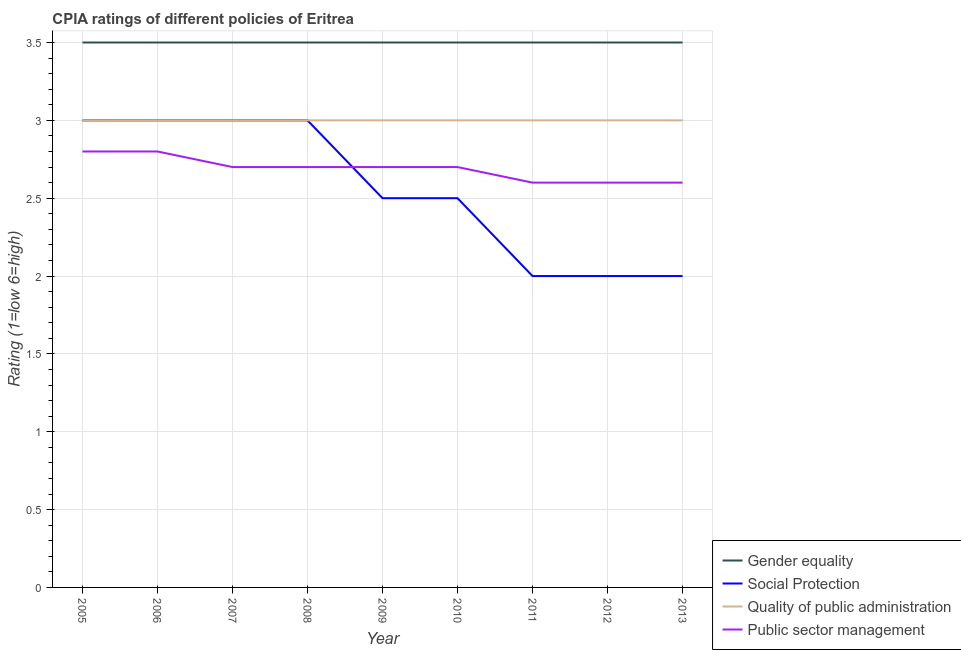Is the number of lines equal to the number of legend labels?
Offer a very short reply. Yes. Across all years, what is the minimum cpia rating of quality of public administration?
Ensure brevity in your answer.  3. What is the total cpia rating of public sector management in the graph?
Your answer should be very brief. 24.2. What is the difference between the cpia rating of gender equality in 2012 and that in 2013?
Your response must be concise. 0. What is the difference between the cpia rating of gender equality in 2011 and the cpia rating of public sector management in 2005?
Ensure brevity in your answer.  0.7. What is the average cpia rating of social protection per year?
Your answer should be very brief. 2.56. In the year 2012, what is the difference between the cpia rating of gender equality and cpia rating of public sector management?
Provide a succinct answer. 0.9. In how many years, is the cpia rating of quality of public administration greater than 2?
Offer a very short reply. 9. What is the ratio of the cpia rating of public sector management in 2005 to that in 2009?
Offer a very short reply. 1.04. What is the difference between the highest and the second highest cpia rating of social protection?
Make the answer very short. 0. What is the difference between the highest and the lowest cpia rating of public sector management?
Make the answer very short. 0.2. Is it the case that in every year, the sum of the cpia rating of social protection and cpia rating of gender equality is greater than the sum of cpia rating of public sector management and cpia rating of quality of public administration?
Keep it short and to the point. No. How many lines are there?
Your answer should be compact. 4. How many years are there in the graph?
Give a very brief answer. 9. What is the difference between two consecutive major ticks on the Y-axis?
Provide a short and direct response. 0.5. Where does the legend appear in the graph?
Provide a succinct answer. Bottom right. How many legend labels are there?
Make the answer very short. 4. What is the title of the graph?
Provide a short and direct response. CPIA ratings of different policies of Eritrea. Does "Quality Certification" appear as one of the legend labels in the graph?
Make the answer very short. No. What is the label or title of the Y-axis?
Provide a succinct answer. Rating (1=low 6=high). What is the Rating (1=low 6=high) of Gender equality in 2005?
Offer a very short reply. 3.5. What is the Rating (1=low 6=high) in Gender equality in 2006?
Provide a short and direct response. 3.5. What is the Rating (1=low 6=high) in Quality of public administration in 2006?
Your response must be concise. 3. What is the Rating (1=low 6=high) of Public sector management in 2006?
Provide a short and direct response. 2.8. What is the Rating (1=low 6=high) in Social Protection in 2008?
Offer a terse response. 3. What is the Rating (1=low 6=high) of Gender equality in 2009?
Your response must be concise. 3.5. What is the Rating (1=low 6=high) of Social Protection in 2009?
Your answer should be compact. 2.5. What is the Rating (1=low 6=high) in Public sector management in 2009?
Make the answer very short. 2.7. What is the Rating (1=low 6=high) in Social Protection in 2010?
Your answer should be compact. 2.5. What is the Rating (1=low 6=high) in Quality of public administration in 2010?
Keep it short and to the point. 3. What is the Rating (1=low 6=high) in Social Protection in 2011?
Give a very brief answer. 2. What is the Rating (1=low 6=high) of Quality of public administration in 2011?
Your answer should be compact. 3. What is the Rating (1=low 6=high) in Public sector management in 2011?
Offer a terse response. 2.6. What is the Rating (1=low 6=high) in Public sector management in 2012?
Give a very brief answer. 2.6. What is the Rating (1=low 6=high) of Gender equality in 2013?
Ensure brevity in your answer.  3.5. What is the Rating (1=low 6=high) of Social Protection in 2013?
Make the answer very short. 2. What is the Rating (1=low 6=high) of Quality of public administration in 2013?
Offer a very short reply. 3. What is the Rating (1=low 6=high) in Public sector management in 2013?
Your answer should be very brief. 2.6. Across all years, what is the maximum Rating (1=low 6=high) of Social Protection?
Give a very brief answer. 3. Across all years, what is the maximum Rating (1=low 6=high) of Quality of public administration?
Ensure brevity in your answer.  3. Across all years, what is the minimum Rating (1=low 6=high) of Gender equality?
Provide a succinct answer. 3.5. What is the total Rating (1=low 6=high) of Gender equality in the graph?
Your answer should be very brief. 31.5. What is the total Rating (1=low 6=high) of Social Protection in the graph?
Your answer should be compact. 23. What is the total Rating (1=low 6=high) in Quality of public administration in the graph?
Provide a succinct answer. 27. What is the total Rating (1=low 6=high) of Public sector management in the graph?
Provide a succinct answer. 24.2. What is the difference between the Rating (1=low 6=high) of Social Protection in 2005 and that in 2006?
Your answer should be compact. 0. What is the difference between the Rating (1=low 6=high) of Public sector management in 2005 and that in 2006?
Provide a succinct answer. 0. What is the difference between the Rating (1=low 6=high) of Social Protection in 2005 and that in 2007?
Give a very brief answer. 0. What is the difference between the Rating (1=low 6=high) in Public sector management in 2005 and that in 2008?
Your answer should be very brief. 0.1. What is the difference between the Rating (1=low 6=high) of Quality of public administration in 2005 and that in 2009?
Provide a short and direct response. 0. What is the difference between the Rating (1=low 6=high) of Social Protection in 2005 and that in 2010?
Your answer should be compact. 0.5. What is the difference between the Rating (1=low 6=high) in Quality of public administration in 2005 and that in 2010?
Offer a terse response. 0. What is the difference between the Rating (1=low 6=high) of Social Protection in 2005 and that in 2011?
Offer a very short reply. 1. What is the difference between the Rating (1=low 6=high) in Public sector management in 2005 and that in 2011?
Provide a short and direct response. 0.2. What is the difference between the Rating (1=low 6=high) in Quality of public administration in 2005 and that in 2012?
Provide a succinct answer. 0. What is the difference between the Rating (1=low 6=high) in Public sector management in 2005 and that in 2012?
Provide a short and direct response. 0.2. What is the difference between the Rating (1=low 6=high) of Gender equality in 2005 and that in 2013?
Keep it short and to the point. 0. What is the difference between the Rating (1=low 6=high) in Social Protection in 2005 and that in 2013?
Provide a succinct answer. 1. What is the difference between the Rating (1=low 6=high) in Gender equality in 2006 and that in 2007?
Provide a succinct answer. 0. What is the difference between the Rating (1=low 6=high) of Public sector management in 2006 and that in 2007?
Provide a short and direct response. 0.1. What is the difference between the Rating (1=low 6=high) in Gender equality in 2006 and that in 2008?
Provide a short and direct response. 0. What is the difference between the Rating (1=low 6=high) in Social Protection in 2006 and that in 2008?
Ensure brevity in your answer.  0. What is the difference between the Rating (1=low 6=high) of Social Protection in 2006 and that in 2009?
Your answer should be very brief. 0.5. What is the difference between the Rating (1=low 6=high) in Quality of public administration in 2006 and that in 2009?
Provide a short and direct response. 0. What is the difference between the Rating (1=low 6=high) in Gender equality in 2006 and that in 2010?
Provide a short and direct response. 0. What is the difference between the Rating (1=low 6=high) in Quality of public administration in 2006 and that in 2010?
Your response must be concise. 0. What is the difference between the Rating (1=low 6=high) in Public sector management in 2006 and that in 2010?
Make the answer very short. 0.1. What is the difference between the Rating (1=low 6=high) in Gender equality in 2006 and that in 2011?
Offer a very short reply. 0. What is the difference between the Rating (1=low 6=high) of Social Protection in 2006 and that in 2011?
Make the answer very short. 1. What is the difference between the Rating (1=low 6=high) of Quality of public administration in 2006 and that in 2011?
Offer a very short reply. 0. What is the difference between the Rating (1=low 6=high) in Gender equality in 2006 and that in 2012?
Ensure brevity in your answer.  0. What is the difference between the Rating (1=low 6=high) in Social Protection in 2006 and that in 2012?
Provide a succinct answer. 1. What is the difference between the Rating (1=low 6=high) in Quality of public administration in 2006 and that in 2012?
Make the answer very short. 0. What is the difference between the Rating (1=low 6=high) in Public sector management in 2006 and that in 2012?
Your answer should be very brief. 0.2. What is the difference between the Rating (1=low 6=high) in Gender equality in 2006 and that in 2013?
Provide a succinct answer. 0. What is the difference between the Rating (1=low 6=high) in Quality of public administration in 2006 and that in 2013?
Your response must be concise. 0. What is the difference between the Rating (1=low 6=high) in Gender equality in 2007 and that in 2008?
Make the answer very short. 0. What is the difference between the Rating (1=low 6=high) of Gender equality in 2007 and that in 2009?
Your response must be concise. 0. What is the difference between the Rating (1=low 6=high) in Social Protection in 2007 and that in 2009?
Offer a terse response. 0.5. What is the difference between the Rating (1=low 6=high) in Gender equality in 2007 and that in 2010?
Provide a succinct answer. 0. What is the difference between the Rating (1=low 6=high) of Quality of public administration in 2007 and that in 2011?
Give a very brief answer. 0. What is the difference between the Rating (1=low 6=high) in Public sector management in 2007 and that in 2011?
Provide a short and direct response. 0.1. What is the difference between the Rating (1=low 6=high) of Gender equality in 2007 and that in 2012?
Offer a very short reply. 0. What is the difference between the Rating (1=low 6=high) of Social Protection in 2007 and that in 2012?
Your response must be concise. 1. What is the difference between the Rating (1=low 6=high) in Quality of public administration in 2007 and that in 2012?
Keep it short and to the point. 0. What is the difference between the Rating (1=low 6=high) in Gender equality in 2008 and that in 2009?
Keep it short and to the point. 0. What is the difference between the Rating (1=low 6=high) of Social Protection in 2008 and that in 2009?
Give a very brief answer. 0.5. What is the difference between the Rating (1=low 6=high) of Public sector management in 2008 and that in 2009?
Offer a very short reply. 0. What is the difference between the Rating (1=low 6=high) of Social Protection in 2008 and that in 2010?
Make the answer very short. 0.5. What is the difference between the Rating (1=low 6=high) of Public sector management in 2008 and that in 2010?
Your answer should be very brief. 0. What is the difference between the Rating (1=low 6=high) of Gender equality in 2008 and that in 2011?
Provide a short and direct response. 0. What is the difference between the Rating (1=low 6=high) of Quality of public administration in 2008 and that in 2011?
Offer a terse response. 0. What is the difference between the Rating (1=low 6=high) in Public sector management in 2008 and that in 2011?
Provide a short and direct response. 0.1. What is the difference between the Rating (1=low 6=high) in Gender equality in 2008 and that in 2012?
Offer a very short reply. 0. What is the difference between the Rating (1=low 6=high) in Social Protection in 2008 and that in 2012?
Your answer should be very brief. 1. What is the difference between the Rating (1=low 6=high) in Public sector management in 2008 and that in 2012?
Offer a terse response. 0.1. What is the difference between the Rating (1=low 6=high) in Public sector management in 2008 and that in 2013?
Your answer should be compact. 0.1. What is the difference between the Rating (1=low 6=high) of Gender equality in 2009 and that in 2010?
Your answer should be very brief. 0. What is the difference between the Rating (1=low 6=high) of Social Protection in 2009 and that in 2010?
Give a very brief answer. 0. What is the difference between the Rating (1=low 6=high) of Public sector management in 2009 and that in 2010?
Your answer should be compact. 0. What is the difference between the Rating (1=low 6=high) of Gender equality in 2009 and that in 2011?
Offer a terse response. 0. What is the difference between the Rating (1=low 6=high) of Social Protection in 2009 and that in 2011?
Give a very brief answer. 0.5. What is the difference between the Rating (1=low 6=high) in Quality of public administration in 2009 and that in 2011?
Provide a short and direct response. 0. What is the difference between the Rating (1=low 6=high) in Public sector management in 2009 and that in 2011?
Offer a very short reply. 0.1. What is the difference between the Rating (1=low 6=high) in Social Protection in 2009 and that in 2013?
Provide a succinct answer. 0.5. What is the difference between the Rating (1=low 6=high) of Quality of public administration in 2009 and that in 2013?
Give a very brief answer. 0. What is the difference between the Rating (1=low 6=high) in Public sector management in 2009 and that in 2013?
Keep it short and to the point. 0.1. What is the difference between the Rating (1=low 6=high) of Social Protection in 2010 and that in 2011?
Keep it short and to the point. 0.5. What is the difference between the Rating (1=low 6=high) in Social Protection in 2010 and that in 2012?
Give a very brief answer. 0.5. What is the difference between the Rating (1=low 6=high) of Public sector management in 2010 and that in 2012?
Your response must be concise. 0.1. What is the difference between the Rating (1=low 6=high) in Gender equality in 2010 and that in 2013?
Give a very brief answer. 0. What is the difference between the Rating (1=low 6=high) in Public sector management in 2010 and that in 2013?
Offer a very short reply. 0.1. What is the difference between the Rating (1=low 6=high) in Gender equality in 2011 and that in 2012?
Keep it short and to the point. 0. What is the difference between the Rating (1=low 6=high) in Social Protection in 2011 and that in 2012?
Your answer should be very brief. 0. What is the difference between the Rating (1=low 6=high) in Public sector management in 2011 and that in 2012?
Ensure brevity in your answer.  0. What is the difference between the Rating (1=low 6=high) in Public sector management in 2011 and that in 2013?
Your answer should be very brief. 0. What is the difference between the Rating (1=low 6=high) of Gender equality in 2012 and that in 2013?
Make the answer very short. 0. What is the difference between the Rating (1=low 6=high) of Social Protection in 2012 and that in 2013?
Give a very brief answer. 0. What is the difference between the Rating (1=low 6=high) of Quality of public administration in 2012 and that in 2013?
Provide a succinct answer. 0. What is the difference between the Rating (1=low 6=high) of Gender equality in 2005 and the Rating (1=low 6=high) of Social Protection in 2006?
Offer a terse response. 0.5. What is the difference between the Rating (1=low 6=high) of Gender equality in 2005 and the Rating (1=low 6=high) of Quality of public administration in 2006?
Provide a short and direct response. 0.5. What is the difference between the Rating (1=low 6=high) of Social Protection in 2005 and the Rating (1=low 6=high) of Quality of public administration in 2006?
Offer a very short reply. 0. What is the difference between the Rating (1=low 6=high) of Social Protection in 2005 and the Rating (1=low 6=high) of Public sector management in 2006?
Make the answer very short. 0.2. What is the difference between the Rating (1=low 6=high) of Quality of public administration in 2005 and the Rating (1=low 6=high) of Public sector management in 2006?
Give a very brief answer. 0.2. What is the difference between the Rating (1=low 6=high) of Gender equality in 2005 and the Rating (1=low 6=high) of Social Protection in 2007?
Ensure brevity in your answer.  0.5. What is the difference between the Rating (1=low 6=high) of Gender equality in 2005 and the Rating (1=low 6=high) of Quality of public administration in 2007?
Give a very brief answer. 0.5. What is the difference between the Rating (1=low 6=high) in Gender equality in 2005 and the Rating (1=low 6=high) in Public sector management in 2007?
Offer a terse response. 0.8. What is the difference between the Rating (1=low 6=high) in Social Protection in 2005 and the Rating (1=low 6=high) in Quality of public administration in 2007?
Give a very brief answer. 0. What is the difference between the Rating (1=low 6=high) in Social Protection in 2005 and the Rating (1=low 6=high) in Public sector management in 2007?
Ensure brevity in your answer.  0.3. What is the difference between the Rating (1=low 6=high) of Quality of public administration in 2005 and the Rating (1=low 6=high) of Public sector management in 2007?
Offer a very short reply. 0.3. What is the difference between the Rating (1=low 6=high) of Gender equality in 2005 and the Rating (1=low 6=high) of Quality of public administration in 2008?
Your answer should be very brief. 0.5. What is the difference between the Rating (1=low 6=high) in Gender equality in 2005 and the Rating (1=low 6=high) in Public sector management in 2008?
Your answer should be very brief. 0.8. What is the difference between the Rating (1=low 6=high) of Social Protection in 2005 and the Rating (1=low 6=high) of Quality of public administration in 2008?
Keep it short and to the point. 0. What is the difference between the Rating (1=low 6=high) of Social Protection in 2005 and the Rating (1=low 6=high) of Public sector management in 2008?
Offer a terse response. 0.3. What is the difference between the Rating (1=low 6=high) in Quality of public administration in 2005 and the Rating (1=low 6=high) in Public sector management in 2008?
Offer a terse response. 0.3. What is the difference between the Rating (1=low 6=high) of Gender equality in 2005 and the Rating (1=low 6=high) of Social Protection in 2009?
Offer a terse response. 1. What is the difference between the Rating (1=low 6=high) in Gender equality in 2005 and the Rating (1=low 6=high) in Quality of public administration in 2009?
Your answer should be compact. 0.5. What is the difference between the Rating (1=low 6=high) in Social Protection in 2005 and the Rating (1=low 6=high) in Quality of public administration in 2009?
Ensure brevity in your answer.  0. What is the difference between the Rating (1=low 6=high) in Social Protection in 2005 and the Rating (1=low 6=high) in Public sector management in 2009?
Give a very brief answer. 0.3. What is the difference between the Rating (1=low 6=high) in Gender equality in 2005 and the Rating (1=low 6=high) in Social Protection in 2010?
Keep it short and to the point. 1. What is the difference between the Rating (1=low 6=high) of Social Protection in 2005 and the Rating (1=low 6=high) of Quality of public administration in 2010?
Your answer should be very brief. 0. What is the difference between the Rating (1=low 6=high) of Social Protection in 2005 and the Rating (1=low 6=high) of Quality of public administration in 2011?
Give a very brief answer. 0. What is the difference between the Rating (1=low 6=high) of Social Protection in 2005 and the Rating (1=low 6=high) of Quality of public administration in 2012?
Offer a very short reply. 0. What is the difference between the Rating (1=low 6=high) of Social Protection in 2005 and the Rating (1=low 6=high) of Public sector management in 2012?
Keep it short and to the point. 0.4. What is the difference between the Rating (1=low 6=high) of Quality of public administration in 2005 and the Rating (1=low 6=high) of Public sector management in 2012?
Keep it short and to the point. 0.4. What is the difference between the Rating (1=low 6=high) of Gender equality in 2005 and the Rating (1=low 6=high) of Quality of public administration in 2013?
Make the answer very short. 0.5. What is the difference between the Rating (1=low 6=high) of Gender equality in 2005 and the Rating (1=low 6=high) of Public sector management in 2013?
Your answer should be very brief. 0.9. What is the difference between the Rating (1=low 6=high) in Social Protection in 2005 and the Rating (1=low 6=high) in Quality of public administration in 2013?
Your answer should be compact. 0. What is the difference between the Rating (1=low 6=high) in Quality of public administration in 2005 and the Rating (1=low 6=high) in Public sector management in 2013?
Your answer should be compact. 0.4. What is the difference between the Rating (1=low 6=high) in Gender equality in 2006 and the Rating (1=low 6=high) in Social Protection in 2007?
Provide a succinct answer. 0.5. What is the difference between the Rating (1=low 6=high) of Social Protection in 2006 and the Rating (1=low 6=high) of Quality of public administration in 2007?
Give a very brief answer. 0. What is the difference between the Rating (1=low 6=high) in Gender equality in 2006 and the Rating (1=low 6=high) in Public sector management in 2008?
Provide a short and direct response. 0.8. What is the difference between the Rating (1=low 6=high) of Social Protection in 2006 and the Rating (1=low 6=high) of Quality of public administration in 2008?
Offer a very short reply. 0. What is the difference between the Rating (1=low 6=high) of Quality of public administration in 2006 and the Rating (1=low 6=high) of Public sector management in 2008?
Ensure brevity in your answer.  0.3. What is the difference between the Rating (1=low 6=high) of Gender equality in 2006 and the Rating (1=low 6=high) of Social Protection in 2009?
Your answer should be compact. 1. What is the difference between the Rating (1=low 6=high) of Gender equality in 2006 and the Rating (1=low 6=high) of Quality of public administration in 2009?
Your response must be concise. 0.5. What is the difference between the Rating (1=low 6=high) in Gender equality in 2006 and the Rating (1=low 6=high) in Public sector management in 2009?
Offer a very short reply. 0.8. What is the difference between the Rating (1=low 6=high) in Social Protection in 2006 and the Rating (1=low 6=high) in Public sector management in 2009?
Your response must be concise. 0.3. What is the difference between the Rating (1=low 6=high) in Quality of public administration in 2006 and the Rating (1=low 6=high) in Public sector management in 2009?
Offer a very short reply. 0.3. What is the difference between the Rating (1=low 6=high) in Gender equality in 2006 and the Rating (1=low 6=high) in Quality of public administration in 2010?
Make the answer very short. 0.5. What is the difference between the Rating (1=low 6=high) of Gender equality in 2006 and the Rating (1=low 6=high) of Public sector management in 2010?
Ensure brevity in your answer.  0.8. What is the difference between the Rating (1=low 6=high) of Social Protection in 2006 and the Rating (1=low 6=high) of Quality of public administration in 2010?
Your response must be concise. 0. What is the difference between the Rating (1=low 6=high) in Gender equality in 2006 and the Rating (1=low 6=high) in Quality of public administration in 2011?
Your response must be concise. 0.5. What is the difference between the Rating (1=low 6=high) in Gender equality in 2006 and the Rating (1=low 6=high) in Public sector management in 2011?
Make the answer very short. 0.9. What is the difference between the Rating (1=low 6=high) in Social Protection in 2006 and the Rating (1=low 6=high) in Public sector management in 2011?
Ensure brevity in your answer.  0.4. What is the difference between the Rating (1=low 6=high) of Quality of public administration in 2006 and the Rating (1=low 6=high) of Public sector management in 2011?
Your answer should be compact. 0.4. What is the difference between the Rating (1=low 6=high) in Gender equality in 2006 and the Rating (1=low 6=high) in Social Protection in 2012?
Make the answer very short. 1.5. What is the difference between the Rating (1=low 6=high) in Gender equality in 2006 and the Rating (1=low 6=high) in Quality of public administration in 2012?
Your answer should be very brief. 0.5. What is the difference between the Rating (1=low 6=high) in Social Protection in 2006 and the Rating (1=low 6=high) in Public sector management in 2012?
Offer a very short reply. 0.4. What is the difference between the Rating (1=low 6=high) in Quality of public administration in 2006 and the Rating (1=low 6=high) in Public sector management in 2012?
Your response must be concise. 0.4. What is the difference between the Rating (1=low 6=high) of Gender equality in 2006 and the Rating (1=low 6=high) of Social Protection in 2013?
Offer a terse response. 1.5. What is the difference between the Rating (1=low 6=high) in Gender equality in 2006 and the Rating (1=low 6=high) in Quality of public administration in 2013?
Your answer should be compact. 0.5. What is the difference between the Rating (1=low 6=high) of Social Protection in 2006 and the Rating (1=low 6=high) of Quality of public administration in 2013?
Your answer should be very brief. 0. What is the difference between the Rating (1=low 6=high) in Gender equality in 2007 and the Rating (1=low 6=high) in Social Protection in 2008?
Your answer should be very brief. 0.5. What is the difference between the Rating (1=low 6=high) in Gender equality in 2007 and the Rating (1=low 6=high) in Social Protection in 2009?
Make the answer very short. 1. What is the difference between the Rating (1=low 6=high) of Gender equality in 2007 and the Rating (1=low 6=high) of Public sector management in 2009?
Your answer should be compact. 0.8. What is the difference between the Rating (1=low 6=high) in Social Protection in 2007 and the Rating (1=low 6=high) in Public sector management in 2009?
Your response must be concise. 0.3. What is the difference between the Rating (1=low 6=high) of Gender equality in 2007 and the Rating (1=low 6=high) of Quality of public administration in 2010?
Your response must be concise. 0.5. What is the difference between the Rating (1=low 6=high) of Social Protection in 2007 and the Rating (1=low 6=high) of Public sector management in 2010?
Offer a terse response. 0.3. What is the difference between the Rating (1=low 6=high) in Quality of public administration in 2007 and the Rating (1=low 6=high) in Public sector management in 2010?
Provide a short and direct response. 0.3. What is the difference between the Rating (1=low 6=high) in Gender equality in 2007 and the Rating (1=low 6=high) in Social Protection in 2011?
Ensure brevity in your answer.  1.5. What is the difference between the Rating (1=low 6=high) of Gender equality in 2007 and the Rating (1=low 6=high) of Quality of public administration in 2012?
Make the answer very short. 0.5. What is the difference between the Rating (1=low 6=high) in Gender equality in 2007 and the Rating (1=low 6=high) in Public sector management in 2012?
Offer a terse response. 0.9. What is the difference between the Rating (1=low 6=high) of Social Protection in 2007 and the Rating (1=low 6=high) of Quality of public administration in 2012?
Ensure brevity in your answer.  0. What is the difference between the Rating (1=low 6=high) in Quality of public administration in 2007 and the Rating (1=low 6=high) in Public sector management in 2012?
Offer a terse response. 0.4. What is the difference between the Rating (1=low 6=high) in Gender equality in 2007 and the Rating (1=low 6=high) in Social Protection in 2013?
Give a very brief answer. 1.5. What is the difference between the Rating (1=low 6=high) in Gender equality in 2007 and the Rating (1=low 6=high) in Public sector management in 2013?
Provide a short and direct response. 0.9. What is the difference between the Rating (1=low 6=high) in Social Protection in 2007 and the Rating (1=low 6=high) in Quality of public administration in 2013?
Ensure brevity in your answer.  0. What is the difference between the Rating (1=low 6=high) in Quality of public administration in 2007 and the Rating (1=low 6=high) in Public sector management in 2013?
Provide a succinct answer. 0.4. What is the difference between the Rating (1=low 6=high) of Gender equality in 2008 and the Rating (1=low 6=high) of Social Protection in 2009?
Offer a very short reply. 1. What is the difference between the Rating (1=low 6=high) of Gender equality in 2008 and the Rating (1=low 6=high) of Quality of public administration in 2009?
Provide a short and direct response. 0.5. What is the difference between the Rating (1=low 6=high) of Social Protection in 2008 and the Rating (1=low 6=high) of Public sector management in 2009?
Offer a terse response. 0.3. What is the difference between the Rating (1=low 6=high) of Quality of public administration in 2008 and the Rating (1=low 6=high) of Public sector management in 2009?
Your response must be concise. 0.3. What is the difference between the Rating (1=low 6=high) of Gender equality in 2008 and the Rating (1=low 6=high) of Quality of public administration in 2010?
Offer a terse response. 0.5. What is the difference between the Rating (1=low 6=high) in Gender equality in 2008 and the Rating (1=low 6=high) in Public sector management in 2010?
Your answer should be compact. 0.8. What is the difference between the Rating (1=low 6=high) in Social Protection in 2008 and the Rating (1=low 6=high) in Quality of public administration in 2010?
Ensure brevity in your answer.  0. What is the difference between the Rating (1=low 6=high) in Quality of public administration in 2008 and the Rating (1=low 6=high) in Public sector management in 2010?
Your answer should be compact. 0.3. What is the difference between the Rating (1=low 6=high) of Gender equality in 2008 and the Rating (1=low 6=high) of Social Protection in 2011?
Your response must be concise. 1.5. What is the difference between the Rating (1=low 6=high) in Gender equality in 2008 and the Rating (1=low 6=high) in Quality of public administration in 2011?
Ensure brevity in your answer.  0.5. What is the difference between the Rating (1=low 6=high) of Gender equality in 2008 and the Rating (1=low 6=high) of Public sector management in 2011?
Your response must be concise. 0.9. What is the difference between the Rating (1=low 6=high) in Social Protection in 2008 and the Rating (1=low 6=high) in Quality of public administration in 2011?
Your answer should be very brief. 0. What is the difference between the Rating (1=low 6=high) of Gender equality in 2008 and the Rating (1=low 6=high) of Social Protection in 2012?
Your answer should be very brief. 1.5. What is the difference between the Rating (1=low 6=high) of Gender equality in 2008 and the Rating (1=low 6=high) of Quality of public administration in 2012?
Give a very brief answer. 0.5. What is the difference between the Rating (1=low 6=high) of Social Protection in 2008 and the Rating (1=low 6=high) of Quality of public administration in 2012?
Offer a terse response. 0. What is the difference between the Rating (1=low 6=high) of Social Protection in 2008 and the Rating (1=low 6=high) of Public sector management in 2012?
Give a very brief answer. 0.4. What is the difference between the Rating (1=low 6=high) of Quality of public administration in 2008 and the Rating (1=low 6=high) of Public sector management in 2012?
Ensure brevity in your answer.  0.4. What is the difference between the Rating (1=low 6=high) in Social Protection in 2008 and the Rating (1=low 6=high) in Quality of public administration in 2013?
Your response must be concise. 0. What is the difference between the Rating (1=low 6=high) in Gender equality in 2009 and the Rating (1=low 6=high) in Quality of public administration in 2010?
Offer a very short reply. 0.5. What is the difference between the Rating (1=low 6=high) of Social Protection in 2009 and the Rating (1=low 6=high) of Quality of public administration in 2010?
Provide a short and direct response. -0.5. What is the difference between the Rating (1=low 6=high) in Gender equality in 2009 and the Rating (1=low 6=high) in Quality of public administration in 2011?
Give a very brief answer. 0.5. What is the difference between the Rating (1=low 6=high) in Social Protection in 2009 and the Rating (1=low 6=high) in Public sector management in 2011?
Make the answer very short. -0.1. What is the difference between the Rating (1=low 6=high) in Social Protection in 2009 and the Rating (1=low 6=high) in Public sector management in 2012?
Ensure brevity in your answer.  -0.1. What is the difference between the Rating (1=low 6=high) of Quality of public administration in 2009 and the Rating (1=low 6=high) of Public sector management in 2012?
Make the answer very short. 0.4. What is the difference between the Rating (1=low 6=high) of Gender equality in 2009 and the Rating (1=low 6=high) of Social Protection in 2013?
Provide a succinct answer. 1.5. What is the difference between the Rating (1=low 6=high) in Gender equality in 2009 and the Rating (1=low 6=high) in Public sector management in 2013?
Make the answer very short. 0.9. What is the difference between the Rating (1=low 6=high) of Quality of public administration in 2009 and the Rating (1=low 6=high) of Public sector management in 2013?
Your response must be concise. 0.4. What is the difference between the Rating (1=low 6=high) of Social Protection in 2010 and the Rating (1=low 6=high) of Public sector management in 2011?
Give a very brief answer. -0.1. What is the difference between the Rating (1=low 6=high) of Quality of public administration in 2010 and the Rating (1=low 6=high) of Public sector management in 2011?
Ensure brevity in your answer.  0.4. What is the difference between the Rating (1=low 6=high) in Gender equality in 2010 and the Rating (1=low 6=high) in Quality of public administration in 2012?
Give a very brief answer. 0.5. What is the difference between the Rating (1=low 6=high) of Social Protection in 2010 and the Rating (1=low 6=high) of Quality of public administration in 2012?
Offer a very short reply. -0.5. What is the difference between the Rating (1=low 6=high) of Social Protection in 2010 and the Rating (1=low 6=high) of Public sector management in 2012?
Make the answer very short. -0.1. What is the difference between the Rating (1=low 6=high) in Social Protection in 2010 and the Rating (1=low 6=high) in Quality of public administration in 2013?
Keep it short and to the point. -0.5. What is the difference between the Rating (1=low 6=high) in Social Protection in 2010 and the Rating (1=low 6=high) in Public sector management in 2013?
Provide a succinct answer. -0.1. What is the difference between the Rating (1=low 6=high) in Quality of public administration in 2010 and the Rating (1=low 6=high) in Public sector management in 2013?
Offer a very short reply. 0.4. What is the difference between the Rating (1=low 6=high) in Gender equality in 2011 and the Rating (1=low 6=high) in Quality of public administration in 2012?
Ensure brevity in your answer.  0.5. What is the difference between the Rating (1=low 6=high) in Quality of public administration in 2011 and the Rating (1=low 6=high) in Public sector management in 2012?
Ensure brevity in your answer.  0.4. What is the difference between the Rating (1=low 6=high) of Gender equality in 2011 and the Rating (1=low 6=high) of Quality of public administration in 2013?
Your response must be concise. 0.5. What is the difference between the Rating (1=low 6=high) in Gender equality in 2011 and the Rating (1=low 6=high) in Public sector management in 2013?
Make the answer very short. 0.9. What is the difference between the Rating (1=low 6=high) in Gender equality in 2012 and the Rating (1=low 6=high) in Social Protection in 2013?
Give a very brief answer. 1.5. What is the difference between the Rating (1=low 6=high) in Gender equality in 2012 and the Rating (1=low 6=high) in Quality of public administration in 2013?
Your answer should be compact. 0.5. What is the difference between the Rating (1=low 6=high) of Quality of public administration in 2012 and the Rating (1=low 6=high) of Public sector management in 2013?
Offer a terse response. 0.4. What is the average Rating (1=low 6=high) in Social Protection per year?
Keep it short and to the point. 2.56. What is the average Rating (1=low 6=high) of Public sector management per year?
Make the answer very short. 2.69. In the year 2005, what is the difference between the Rating (1=low 6=high) of Gender equality and Rating (1=low 6=high) of Public sector management?
Your answer should be compact. 0.7. In the year 2005, what is the difference between the Rating (1=low 6=high) of Social Protection and Rating (1=low 6=high) of Public sector management?
Provide a short and direct response. 0.2. In the year 2005, what is the difference between the Rating (1=low 6=high) in Quality of public administration and Rating (1=low 6=high) in Public sector management?
Provide a succinct answer. 0.2. In the year 2006, what is the difference between the Rating (1=low 6=high) of Gender equality and Rating (1=low 6=high) of Social Protection?
Ensure brevity in your answer.  0.5. In the year 2006, what is the difference between the Rating (1=low 6=high) of Gender equality and Rating (1=low 6=high) of Public sector management?
Your answer should be very brief. 0.7. In the year 2007, what is the difference between the Rating (1=low 6=high) of Gender equality and Rating (1=low 6=high) of Quality of public administration?
Keep it short and to the point. 0.5. In the year 2007, what is the difference between the Rating (1=low 6=high) in Gender equality and Rating (1=low 6=high) in Public sector management?
Keep it short and to the point. 0.8. In the year 2007, what is the difference between the Rating (1=low 6=high) of Social Protection and Rating (1=low 6=high) of Quality of public administration?
Offer a terse response. 0. In the year 2007, what is the difference between the Rating (1=low 6=high) of Quality of public administration and Rating (1=low 6=high) of Public sector management?
Make the answer very short. 0.3. In the year 2008, what is the difference between the Rating (1=low 6=high) in Gender equality and Rating (1=low 6=high) in Social Protection?
Offer a terse response. 0.5. In the year 2008, what is the difference between the Rating (1=low 6=high) of Gender equality and Rating (1=low 6=high) of Quality of public administration?
Provide a succinct answer. 0.5. In the year 2008, what is the difference between the Rating (1=low 6=high) in Social Protection and Rating (1=low 6=high) in Quality of public administration?
Your response must be concise. 0. In the year 2008, what is the difference between the Rating (1=low 6=high) of Quality of public administration and Rating (1=low 6=high) of Public sector management?
Give a very brief answer. 0.3. In the year 2009, what is the difference between the Rating (1=low 6=high) in Gender equality and Rating (1=low 6=high) in Quality of public administration?
Ensure brevity in your answer.  0.5. In the year 2009, what is the difference between the Rating (1=low 6=high) of Social Protection and Rating (1=low 6=high) of Public sector management?
Ensure brevity in your answer.  -0.2. In the year 2009, what is the difference between the Rating (1=low 6=high) in Quality of public administration and Rating (1=low 6=high) in Public sector management?
Your response must be concise. 0.3. In the year 2010, what is the difference between the Rating (1=low 6=high) of Gender equality and Rating (1=low 6=high) of Quality of public administration?
Ensure brevity in your answer.  0.5. In the year 2010, what is the difference between the Rating (1=low 6=high) of Gender equality and Rating (1=low 6=high) of Public sector management?
Keep it short and to the point. 0.8. In the year 2010, what is the difference between the Rating (1=low 6=high) of Quality of public administration and Rating (1=low 6=high) of Public sector management?
Provide a short and direct response. 0.3. In the year 2011, what is the difference between the Rating (1=low 6=high) of Gender equality and Rating (1=low 6=high) of Social Protection?
Ensure brevity in your answer.  1.5. In the year 2011, what is the difference between the Rating (1=low 6=high) in Gender equality and Rating (1=low 6=high) in Quality of public administration?
Ensure brevity in your answer.  0.5. In the year 2011, what is the difference between the Rating (1=low 6=high) in Gender equality and Rating (1=low 6=high) in Public sector management?
Offer a terse response. 0.9. In the year 2013, what is the difference between the Rating (1=low 6=high) in Gender equality and Rating (1=low 6=high) in Social Protection?
Provide a succinct answer. 1.5. In the year 2013, what is the difference between the Rating (1=low 6=high) in Gender equality and Rating (1=low 6=high) in Public sector management?
Ensure brevity in your answer.  0.9. In the year 2013, what is the difference between the Rating (1=low 6=high) of Social Protection and Rating (1=low 6=high) of Public sector management?
Provide a short and direct response. -0.6. In the year 2013, what is the difference between the Rating (1=low 6=high) in Quality of public administration and Rating (1=low 6=high) in Public sector management?
Make the answer very short. 0.4. What is the ratio of the Rating (1=low 6=high) of Gender equality in 2005 to that in 2006?
Keep it short and to the point. 1. What is the ratio of the Rating (1=low 6=high) in Gender equality in 2005 to that in 2007?
Your answer should be very brief. 1. What is the ratio of the Rating (1=low 6=high) of Social Protection in 2005 to that in 2007?
Keep it short and to the point. 1. What is the ratio of the Rating (1=low 6=high) in Public sector management in 2005 to that in 2007?
Your answer should be compact. 1.04. What is the ratio of the Rating (1=low 6=high) in Gender equality in 2005 to that in 2008?
Your answer should be very brief. 1. What is the ratio of the Rating (1=low 6=high) in Gender equality in 2005 to that in 2009?
Offer a very short reply. 1. What is the ratio of the Rating (1=low 6=high) of Quality of public administration in 2005 to that in 2009?
Offer a very short reply. 1. What is the ratio of the Rating (1=low 6=high) in Social Protection in 2005 to that in 2011?
Keep it short and to the point. 1.5. What is the ratio of the Rating (1=low 6=high) in Quality of public administration in 2005 to that in 2011?
Provide a succinct answer. 1. What is the ratio of the Rating (1=low 6=high) in Quality of public administration in 2005 to that in 2012?
Your answer should be very brief. 1. What is the ratio of the Rating (1=low 6=high) of Social Protection in 2005 to that in 2013?
Make the answer very short. 1.5. What is the ratio of the Rating (1=low 6=high) of Social Protection in 2006 to that in 2007?
Ensure brevity in your answer.  1. What is the ratio of the Rating (1=low 6=high) of Gender equality in 2006 to that in 2009?
Offer a very short reply. 1. What is the ratio of the Rating (1=low 6=high) of Social Protection in 2006 to that in 2009?
Your response must be concise. 1.2. What is the ratio of the Rating (1=low 6=high) in Public sector management in 2006 to that in 2009?
Your answer should be very brief. 1.04. What is the ratio of the Rating (1=low 6=high) of Gender equality in 2006 to that in 2010?
Your answer should be compact. 1. What is the ratio of the Rating (1=low 6=high) of Public sector management in 2006 to that in 2010?
Your answer should be compact. 1.04. What is the ratio of the Rating (1=low 6=high) of Gender equality in 2006 to that in 2011?
Provide a succinct answer. 1. What is the ratio of the Rating (1=low 6=high) in Quality of public administration in 2006 to that in 2011?
Offer a terse response. 1. What is the ratio of the Rating (1=low 6=high) of Gender equality in 2006 to that in 2012?
Your answer should be very brief. 1. What is the ratio of the Rating (1=low 6=high) of Social Protection in 2006 to that in 2012?
Offer a very short reply. 1.5. What is the ratio of the Rating (1=low 6=high) in Quality of public administration in 2006 to that in 2012?
Offer a very short reply. 1. What is the ratio of the Rating (1=low 6=high) of Social Protection in 2006 to that in 2013?
Make the answer very short. 1.5. What is the ratio of the Rating (1=low 6=high) of Quality of public administration in 2006 to that in 2013?
Provide a succinct answer. 1. What is the ratio of the Rating (1=low 6=high) of Public sector management in 2006 to that in 2013?
Provide a succinct answer. 1.08. What is the ratio of the Rating (1=low 6=high) of Gender equality in 2007 to that in 2008?
Offer a very short reply. 1. What is the ratio of the Rating (1=low 6=high) of Social Protection in 2007 to that in 2008?
Offer a terse response. 1. What is the ratio of the Rating (1=low 6=high) of Quality of public administration in 2007 to that in 2008?
Make the answer very short. 1. What is the ratio of the Rating (1=low 6=high) in Gender equality in 2007 to that in 2009?
Offer a very short reply. 1. What is the ratio of the Rating (1=low 6=high) of Social Protection in 2007 to that in 2009?
Make the answer very short. 1.2. What is the ratio of the Rating (1=low 6=high) in Quality of public administration in 2007 to that in 2009?
Provide a short and direct response. 1. What is the ratio of the Rating (1=low 6=high) of Public sector management in 2007 to that in 2009?
Ensure brevity in your answer.  1. What is the ratio of the Rating (1=low 6=high) of Gender equality in 2007 to that in 2010?
Offer a very short reply. 1. What is the ratio of the Rating (1=low 6=high) in Social Protection in 2007 to that in 2010?
Make the answer very short. 1.2. What is the ratio of the Rating (1=low 6=high) of Quality of public administration in 2007 to that in 2010?
Offer a very short reply. 1. What is the ratio of the Rating (1=low 6=high) of Social Protection in 2007 to that in 2011?
Provide a short and direct response. 1.5. What is the ratio of the Rating (1=low 6=high) of Quality of public administration in 2007 to that in 2011?
Provide a short and direct response. 1. What is the ratio of the Rating (1=low 6=high) in Public sector management in 2007 to that in 2011?
Your response must be concise. 1.04. What is the ratio of the Rating (1=low 6=high) of Gender equality in 2007 to that in 2012?
Provide a succinct answer. 1. What is the ratio of the Rating (1=low 6=high) of Quality of public administration in 2007 to that in 2012?
Your answer should be compact. 1. What is the ratio of the Rating (1=low 6=high) in Gender equality in 2008 to that in 2009?
Keep it short and to the point. 1. What is the ratio of the Rating (1=low 6=high) of Gender equality in 2008 to that in 2010?
Your answer should be very brief. 1. What is the ratio of the Rating (1=low 6=high) of Social Protection in 2008 to that in 2010?
Offer a very short reply. 1.2. What is the ratio of the Rating (1=low 6=high) in Quality of public administration in 2008 to that in 2010?
Provide a short and direct response. 1. What is the ratio of the Rating (1=low 6=high) in Gender equality in 2008 to that in 2011?
Your answer should be compact. 1. What is the ratio of the Rating (1=low 6=high) in Social Protection in 2008 to that in 2011?
Your answer should be very brief. 1.5. What is the ratio of the Rating (1=low 6=high) in Quality of public administration in 2008 to that in 2011?
Offer a terse response. 1. What is the ratio of the Rating (1=low 6=high) in Gender equality in 2008 to that in 2012?
Give a very brief answer. 1. What is the ratio of the Rating (1=low 6=high) of Social Protection in 2008 to that in 2012?
Provide a short and direct response. 1.5. What is the ratio of the Rating (1=low 6=high) in Gender equality in 2008 to that in 2013?
Provide a succinct answer. 1. What is the ratio of the Rating (1=low 6=high) of Public sector management in 2008 to that in 2013?
Offer a terse response. 1.04. What is the ratio of the Rating (1=low 6=high) in Social Protection in 2009 to that in 2010?
Provide a short and direct response. 1. What is the ratio of the Rating (1=low 6=high) in Public sector management in 2009 to that in 2010?
Keep it short and to the point. 1. What is the ratio of the Rating (1=low 6=high) in Gender equality in 2009 to that in 2011?
Make the answer very short. 1. What is the ratio of the Rating (1=low 6=high) of Social Protection in 2009 to that in 2011?
Provide a short and direct response. 1.25. What is the ratio of the Rating (1=low 6=high) of Quality of public administration in 2009 to that in 2011?
Give a very brief answer. 1. What is the ratio of the Rating (1=low 6=high) of Gender equality in 2009 to that in 2012?
Offer a very short reply. 1. What is the ratio of the Rating (1=low 6=high) in Social Protection in 2009 to that in 2012?
Your answer should be very brief. 1.25. What is the ratio of the Rating (1=low 6=high) of Social Protection in 2009 to that in 2013?
Offer a terse response. 1.25. What is the ratio of the Rating (1=low 6=high) of Social Protection in 2010 to that in 2011?
Give a very brief answer. 1.25. What is the ratio of the Rating (1=low 6=high) of Quality of public administration in 2010 to that in 2011?
Your answer should be very brief. 1. What is the ratio of the Rating (1=low 6=high) of Gender equality in 2010 to that in 2012?
Offer a very short reply. 1. What is the ratio of the Rating (1=low 6=high) in Social Protection in 2010 to that in 2012?
Ensure brevity in your answer.  1.25. What is the ratio of the Rating (1=low 6=high) in Quality of public administration in 2010 to that in 2012?
Offer a terse response. 1. What is the ratio of the Rating (1=low 6=high) in Public sector management in 2010 to that in 2012?
Your response must be concise. 1.04. What is the ratio of the Rating (1=low 6=high) in Gender equality in 2010 to that in 2013?
Provide a short and direct response. 1. What is the ratio of the Rating (1=low 6=high) of Quality of public administration in 2010 to that in 2013?
Offer a terse response. 1. What is the ratio of the Rating (1=low 6=high) of Social Protection in 2011 to that in 2012?
Make the answer very short. 1. What is the ratio of the Rating (1=low 6=high) of Quality of public administration in 2011 to that in 2012?
Offer a very short reply. 1. What is the ratio of the Rating (1=low 6=high) of Public sector management in 2011 to that in 2012?
Your answer should be compact. 1. What is the ratio of the Rating (1=low 6=high) in Gender equality in 2011 to that in 2013?
Ensure brevity in your answer.  1. What is the ratio of the Rating (1=low 6=high) of Social Protection in 2011 to that in 2013?
Keep it short and to the point. 1. What is the ratio of the Rating (1=low 6=high) in Quality of public administration in 2011 to that in 2013?
Keep it short and to the point. 1. What is the ratio of the Rating (1=low 6=high) in Gender equality in 2012 to that in 2013?
Offer a terse response. 1. What is the ratio of the Rating (1=low 6=high) in Social Protection in 2012 to that in 2013?
Offer a terse response. 1. What is the ratio of the Rating (1=low 6=high) in Quality of public administration in 2012 to that in 2013?
Your answer should be compact. 1. What is the ratio of the Rating (1=low 6=high) in Public sector management in 2012 to that in 2013?
Give a very brief answer. 1. What is the difference between the highest and the second highest Rating (1=low 6=high) in Public sector management?
Give a very brief answer. 0. What is the difference between the highest and the lowest Rating (1=low 6=high) of Social Protection?
Ensure brevity in your answer.  1. 